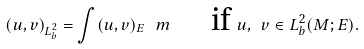<formula> <loc_0><loc_0><loc_500><loc_500>( u , v ) _ { L ^ { 2 } _ { b } } = \int ( u , v ) _ { E } \, \ m \quad \text { if } u , \ v \in L ^ { 2 } _ { b } ( M ; E ) .</formula> 